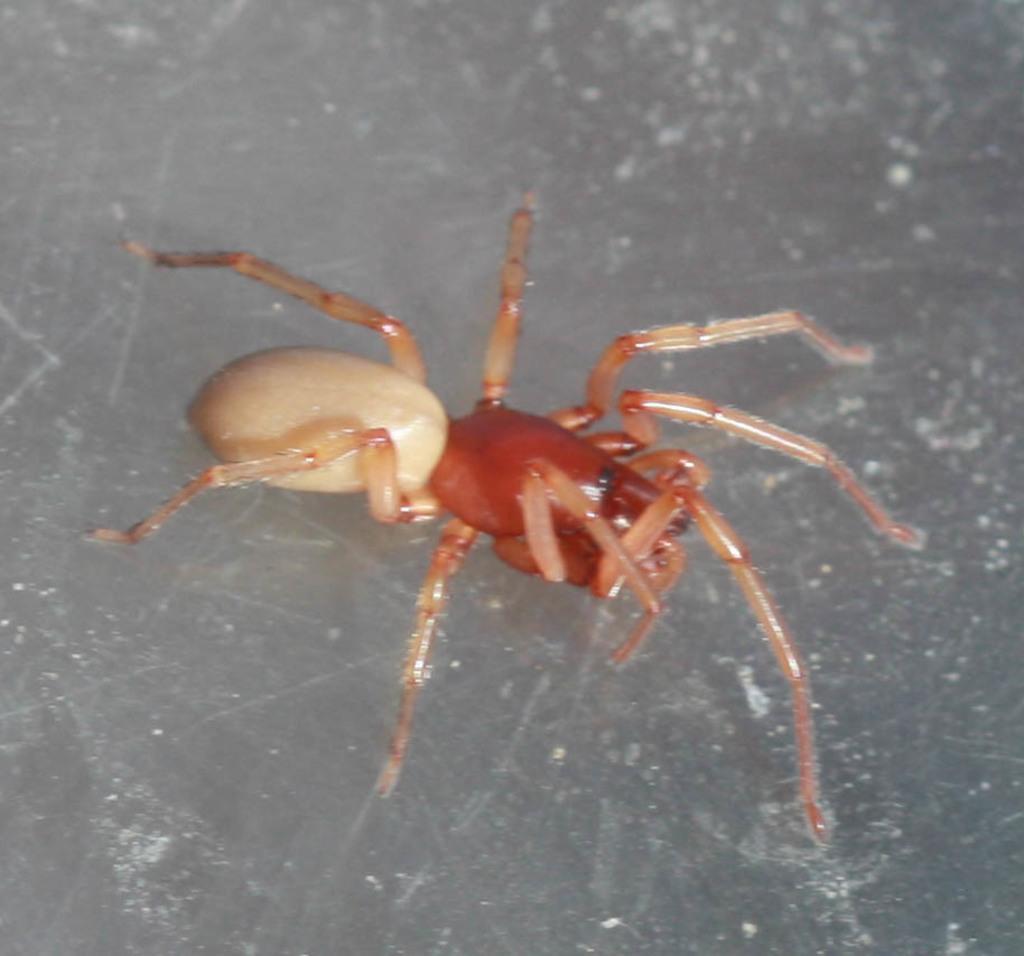Describe this image in one or two sentences. In this picture we can see a spider. 